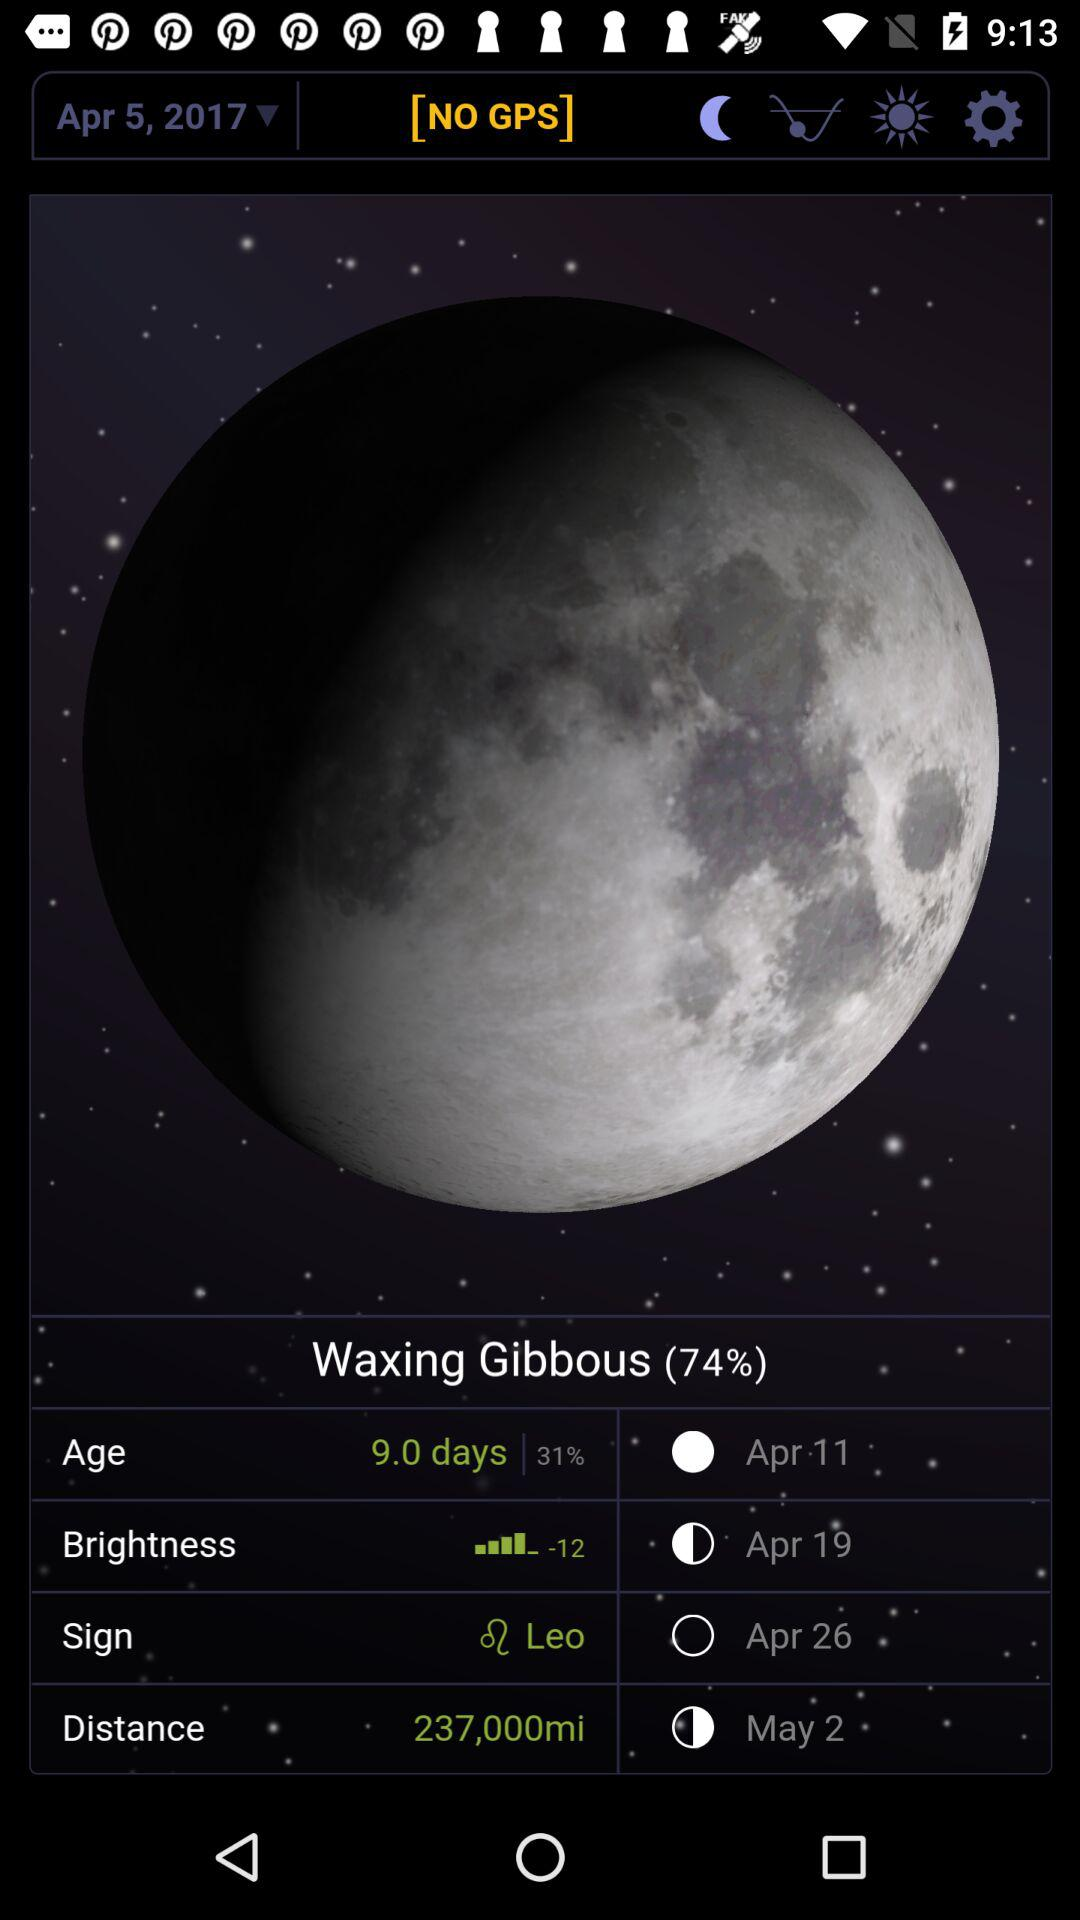What is the date? The date is April 5, 2017. 